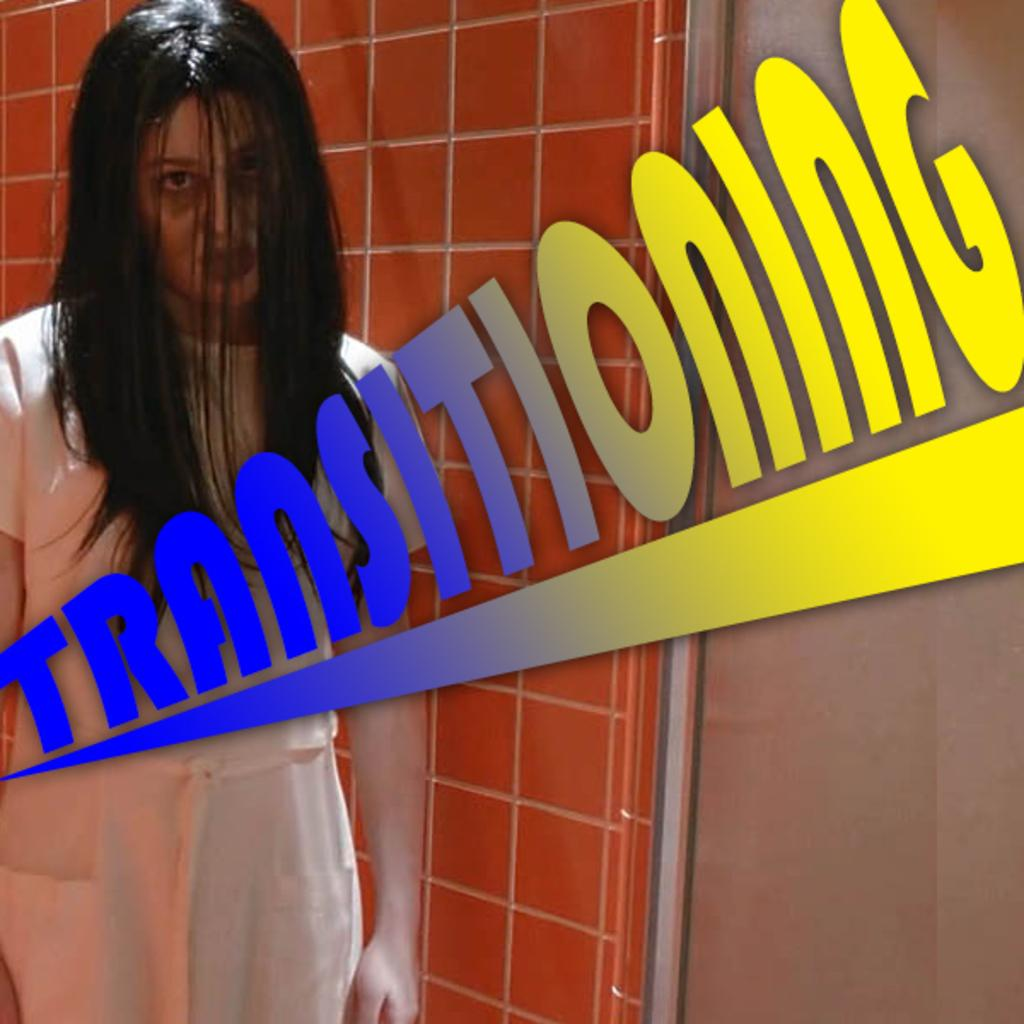<image>
Share a concise interpretation of the image provided. A meme of a young woman includes the word Transitioning. 